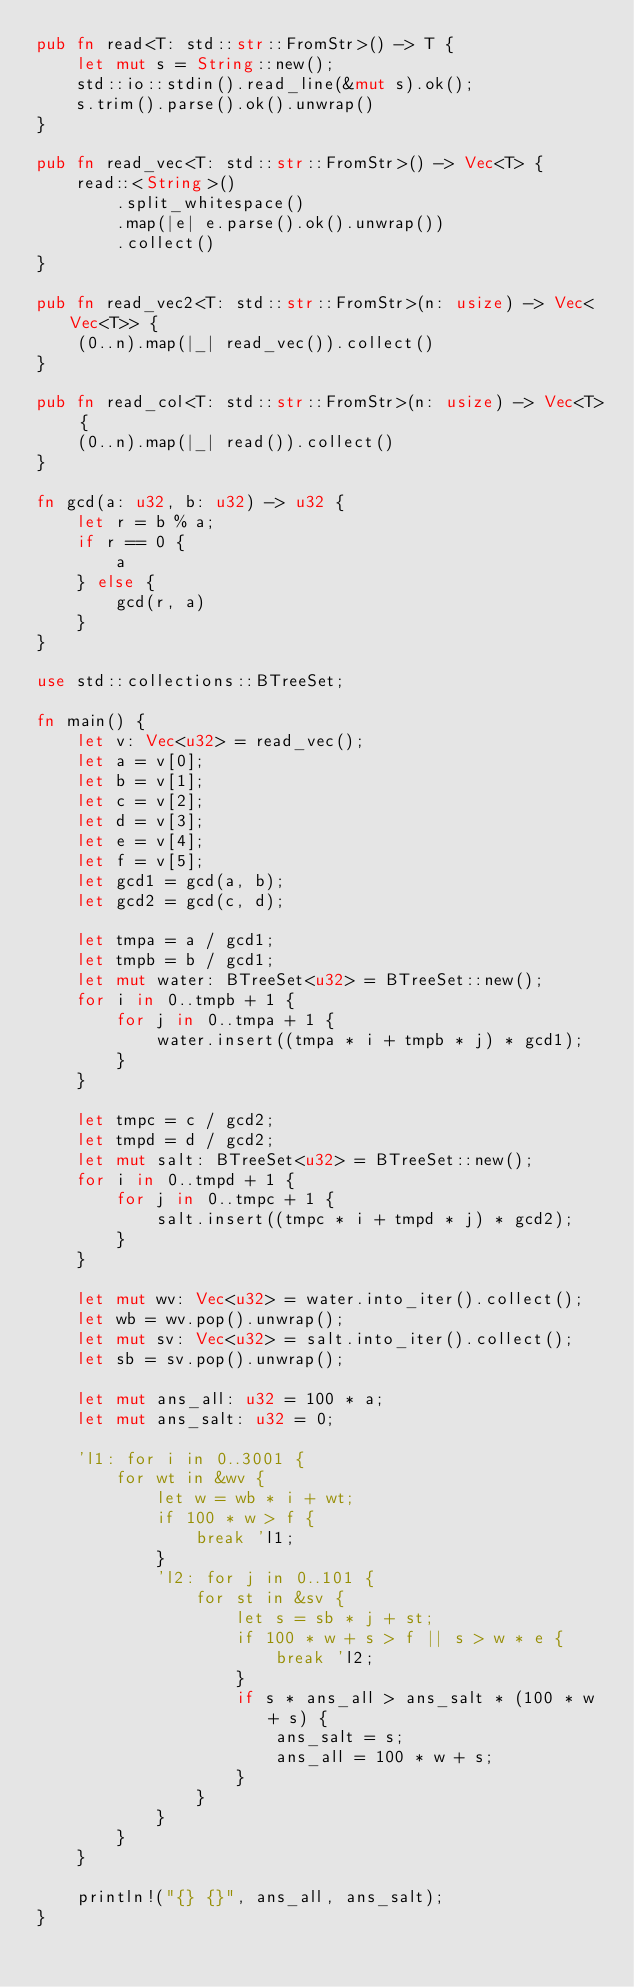Convert code to text. <code><loc_0><loc_0><loc_500><loc_500><_Rust_>pub fn read<T: std::str::FromStr>() -> T {
    let mut s = String::new();
    std::io::stdin().read_line(&mut s).ok();
    s.trim().parse().ok().unwrap()
}

pub fn read_vec<T: std::str::FromStr>() -> Vec<T> {
    read::<String>()
        .split_whitespace()
        .map(|e| e.parse().ok().unwrap())
        .collect()
}

pub fn read_vec2<T: std::str::FromStr>(n: usize) -> Vec<Vec<T>> {
    (0..n).map(|_| read_vec()).collect()
}

pub fn read_col<T: std::str::FromStr>(n: usize) -> Vec<T> {
    (0..n).map(|_| read()).collect()
}

fn gcd(a: u32, b: u32) -> u32 {
    let r = b % a;
    if r == 0 {
        a
    } else {
        gcd(r, a)
    }
}

use std::collections::BTreeSet;

fn main() {
    let v: Vec<u32> = read_vec();
    let a = v[0];
    let b = v[1];
    let c = v[2];
    let d = v[3];
    let e = v[4];
    let f = v[5];
    let gcd1 = gcd(a, b);
    let gcd2 = gcd(c, d);

    let tmpa = a / gcd1;
    let tmpb = b / gcd1;
    let mut water: BTreeSet<u32> = BTreeSet::new();
    for i in 0..tmpb + 1 {
        for j in 0..tmpa + 1 {
            water.insert((tmpa * i + tmpb * j) * gcd1);
        }
    }

    let tmpc = c / gcd2;
    let tmpd = d / gcd2;
    let mut salt: BTreeSet<u32> = BTreeSet::new();
    for i in 0..tmpd + 1 {
        for j in 0..tmpc + 1 {
            salt.insert((tmpc * i + tmpd * j) * gcd2);
        }
    }

    let mut wv: Vec<u32> = water.into_iter().collect();
    let wb = wv.pop().unwrap();
    let mut sv: Vec<u32> = salt.into_iter().collect();
    let sb = sv.pop().unwrap();

    let mut ans_all: u32 = 100 * a;
    let mut ans_salt: u32 = 0;

    'l1: for i in 0..3001 {
        for wt in &wv {
            let w = wb * i + wt;
            if 100 * w > f {
                break 'l1;
            }
            'l2: for j in 0..101 {
                for st in &sv {
                    let s = sb * j + st;
                    if 100 * w + s > f || s > w * e {
                        break 'l2;
                    }
                    if s * ans_all > ans_salt * (100 * w + s) {
                        ans_salt = s;
                        ans_all = 100 * w + s;
                    }
                }
            }
        }
    }

    println!("{} {}", ans_all, ans_salt);
}
</code> 